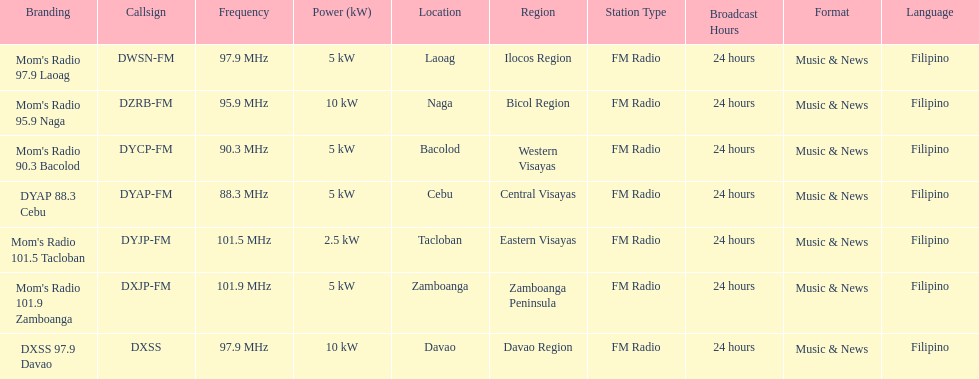How many of these stations have a broadcast frequency over 100 mhz? 2. Can you parse all the data within this table? {'header': ['Branding', 'Callsign', 'Frequency', 'Power (kW)', 'Location', 'Region', 'Station Type', 'Broadcast Hours', 'Format', 'Language'], 'rows': [["Mom's Radio 97.9 Laoag", 'DWSN-FM', '97.9\xa0MHz', '5\xa0kW', 'Laoag', 'Ilocos Region', 'FM Radio', '24 hours', 'Music & News', 'Filipino'], ["Mom's Radio 95.9 Naga", 'DZRB-FM', '95.9\xa0MHz', '10\xa0kW', 'Naga', 'Bicol Region', 'FM Radio', '24 hours', 'Music & News', 'Filipino'], ["Mom's Radio 90.3 Bacolod", 'DYCP-FM', '90.3\xa0MHz', '5\xa0kW', 'Bacolod', 'Western Visayas', 'FM Radio', '24 hours', 'Music & News', 'Filipino'], ['DYAP 88.3 Cebu', 'DYAP-FM', '88.3\xa0MHz', '5\xa0kW', 'Cebu', 'Central Visayas', 'FM Radio', '24 hours', 'Music & News', 'Filipino'], ["Mom's Radio 101.5 Tacloban", 'DYJP-FM', '101.5\xa0MHz', '2.5\xa0kW', 'Tacloban', 'Eastern Visayas', 'FM Radio', '24 hours', 'Music & News', 'Filipino'], ["Mom's Radio 101.9 Zamboanga", 'DXJP-FM', '101.9\xa0MHz', '5\xa0kW', 'Zamboanga', 'Zamboanga Peninsula', 'FM Radio', '24 hours', 'Music & News', 'Filipino'], ['DXSS 97.9 Davao', 'DXSS', '97.9\xa0MHz', '10\xa0kW', 'Davao', 'Davao Region', 'FM Radio', '24 hours', 'Music & News', 'Filipino']]} 